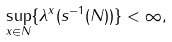Convert formula to latex. <formula><loc_0><loc_0><loc_500><loc_500>\sup _ { x \in N } \{ \lambda ^ { x } ( s ^ { - 1 } ( N ) ) \} < \infty ,</formula> 